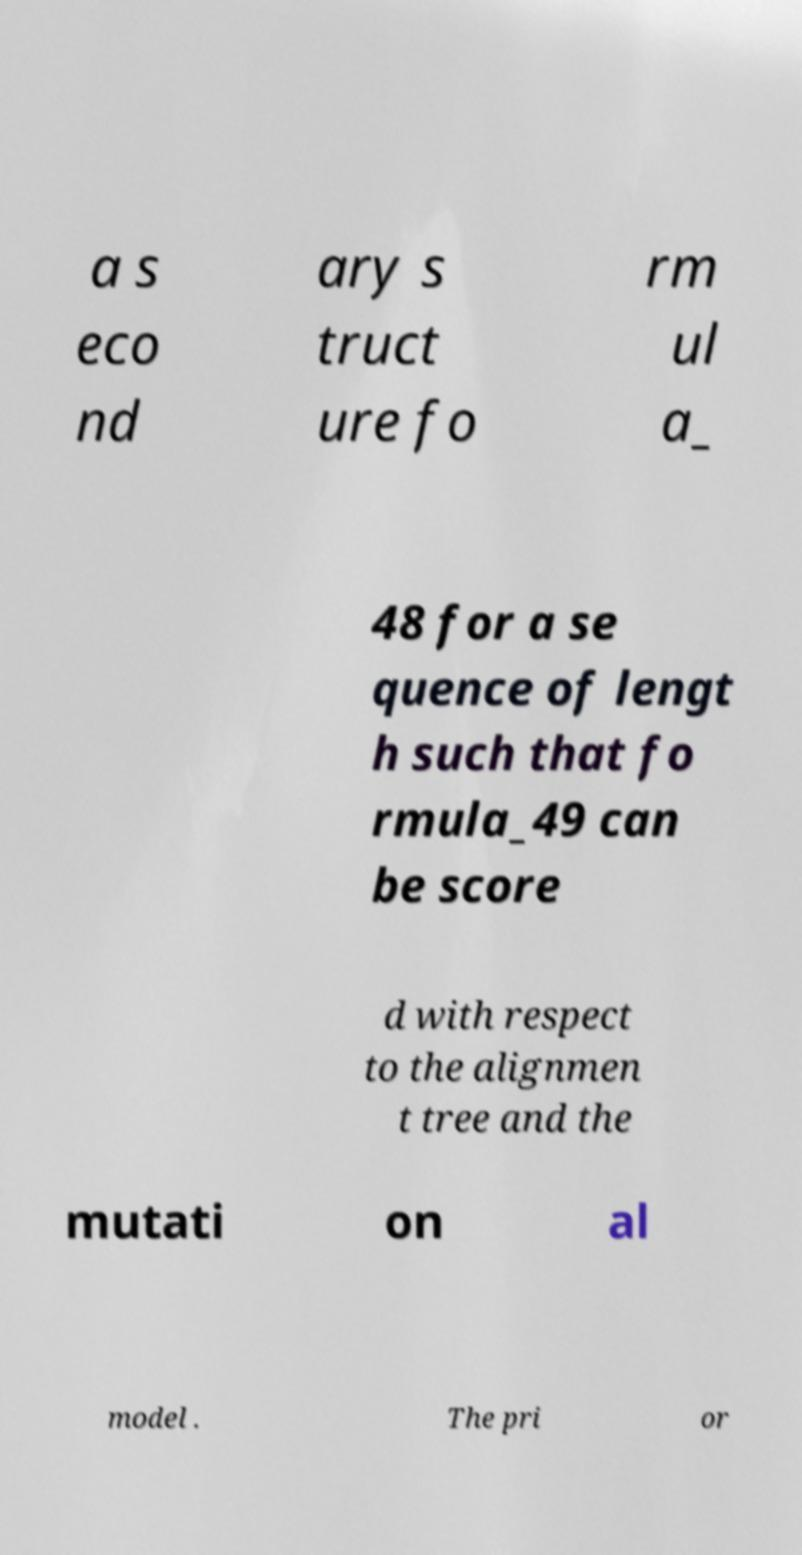For documentation purposes, I need the text within this image transcribed. Could you provide that? a s eco nd ary s truct ure fo rm ul a_ 48 for a se quence of lengt h such that fo rmula_49 can be score d with respect to the alignmen t tree and the mutati on al model . The pri or 